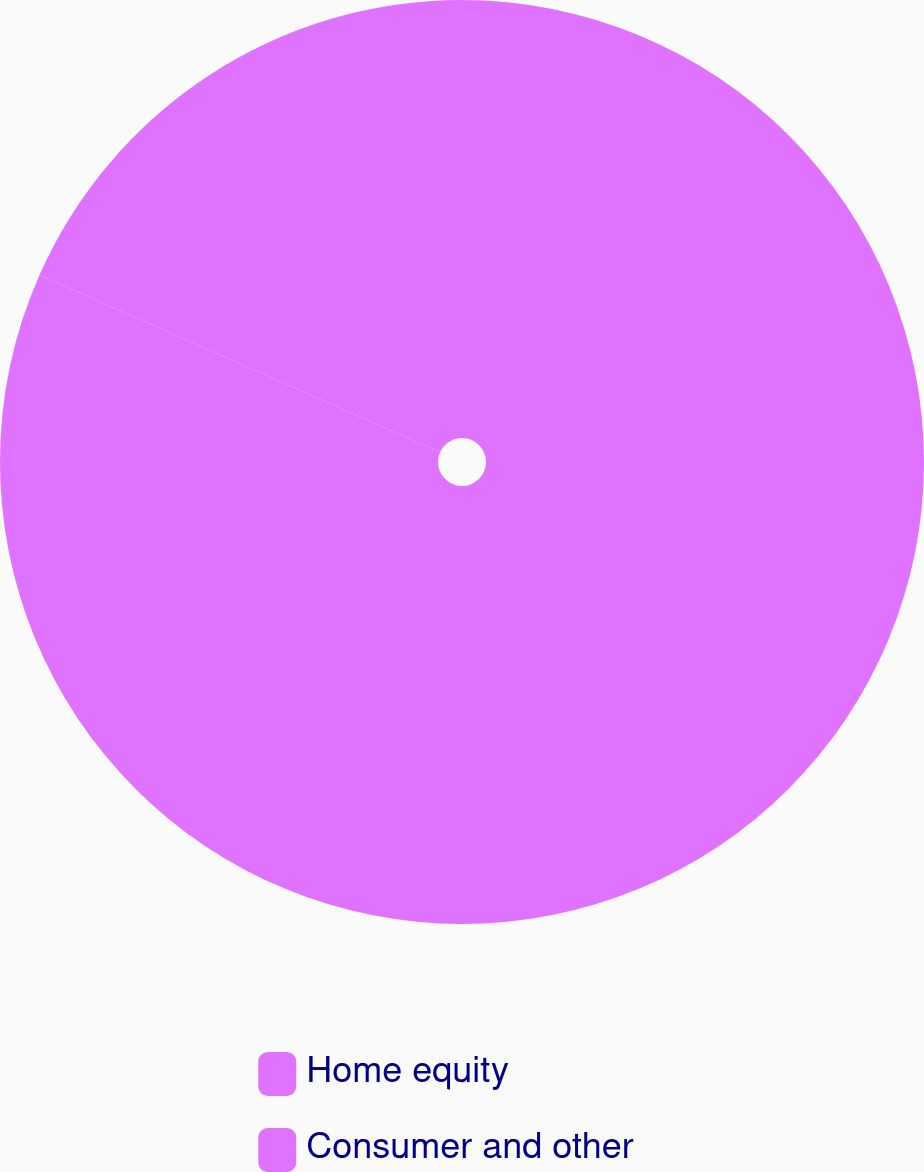Convert chart to OTSL. <chart><loc_0><loc_0><loc_500><loc_500><pie_chart><fcel>Home equity<fcel>Consumer and other<nl><fcel>81.63%<fcel>18.37%<nl></chart> 